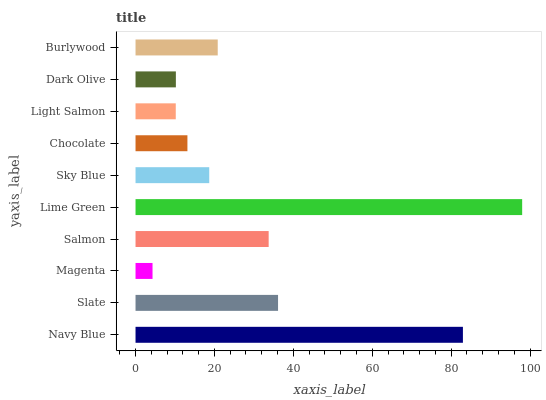Is Magenta the minimum?
Answer yes or no. Yes. Is Lime Green the maximum?
Answer yes or no. Yes. Is Slate the minimum?
Answer yes or no. No. Is Slate the maximum?
Answer yes or no. No. Is Navy Blue greater than Slate?
Answer yes or no. Yes. Is Slate less than Navy Blue?
Answer yes or no. Yes. Is Slate greater than Navy Blue?
Answer yes or no. No. Is Navy Blue less than Slate?
Answer yes or no. No. Is Burlywood the high median?
Answer yes or no. Yes. Is Sky Blue the low median?
Answer yes or no. Yes. Is Lime Green the high median?
Answer yes or no. No. Is Burlywood the low median?
Answer yes or no. No. 